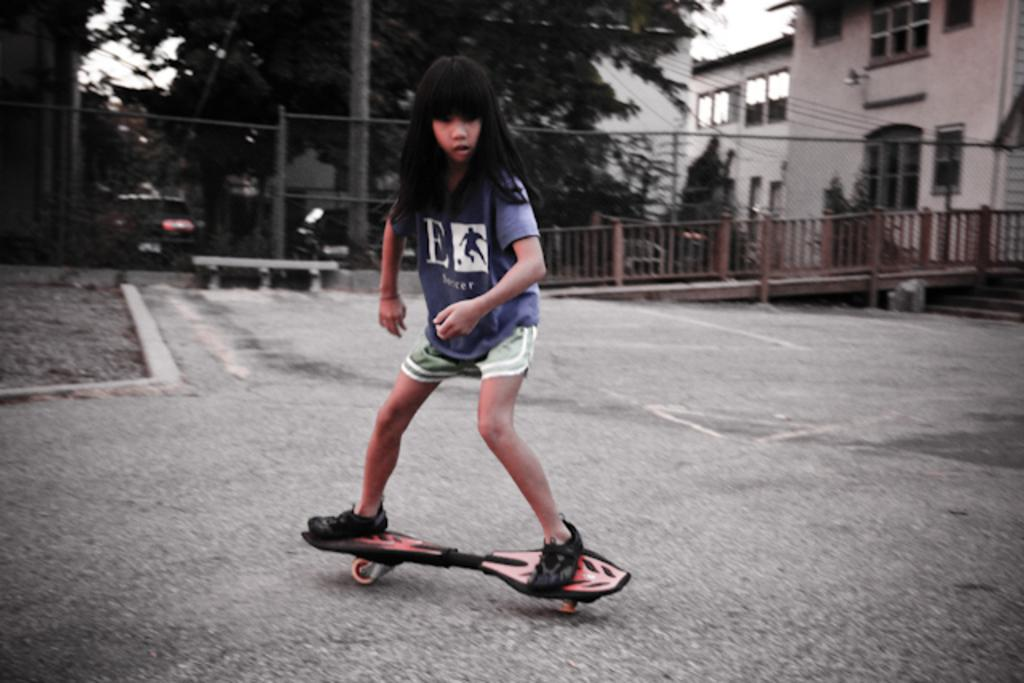Who is the main subject in the image? There is a girl in the image. What is the girl doing in the image? The girl is on a skateboard. What can be seen in the foreground of the image? There are poles in the image. What is present on the right side of the image? There is fencing on the right side of the image. What is visible in the background of the image? There are trees and buildings in the background of the image. Can you tell me how many times the girl touches the bridge in the image? There is no bridge present in the image, so the girl cannot touch it. 